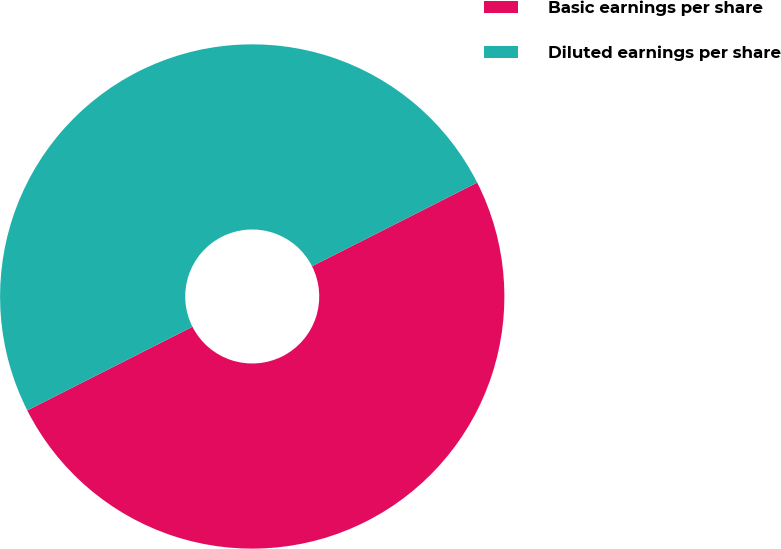Convert chart to OTSL. <chart><loc_0><loc_0><loc_500><loc_500><pie_chart><fcel>Basic earnings per share<fcel>Diluted earnings per share<nl><fcel>50.0%<fcel>50.0%<nl></chart> 